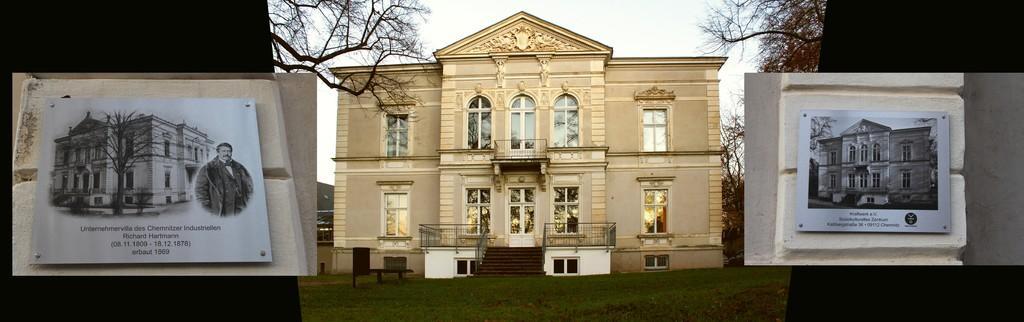In one or two sentences, can you explain what this image depicts? On the either side of the image we can see frames fixed to the wall in which we can see building, we can see a person standing here, some text and trees. At the center of the image we can see a house, grass, trees and the sky in the background. 